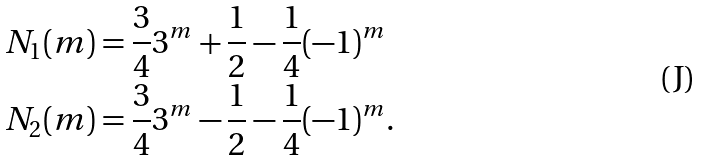<formula> <loc_0><loc_0><loc_500><loc_500>& N _ { 1 } ( m ) = \frac { 3 } { 4 } 3 ^ { m } + \frac { 1 } { 2 } - \frac { 1 } { 4 } ( - 1 ) ^ { m } \\ & N _ { 2 } ( m ) = \frac { 3 } { 4 } 3 ^ { m } - \frac { 1 } { 2 } - \frac { 1 } { 4 } ( - 1 ) ^ { m } .</formula> 